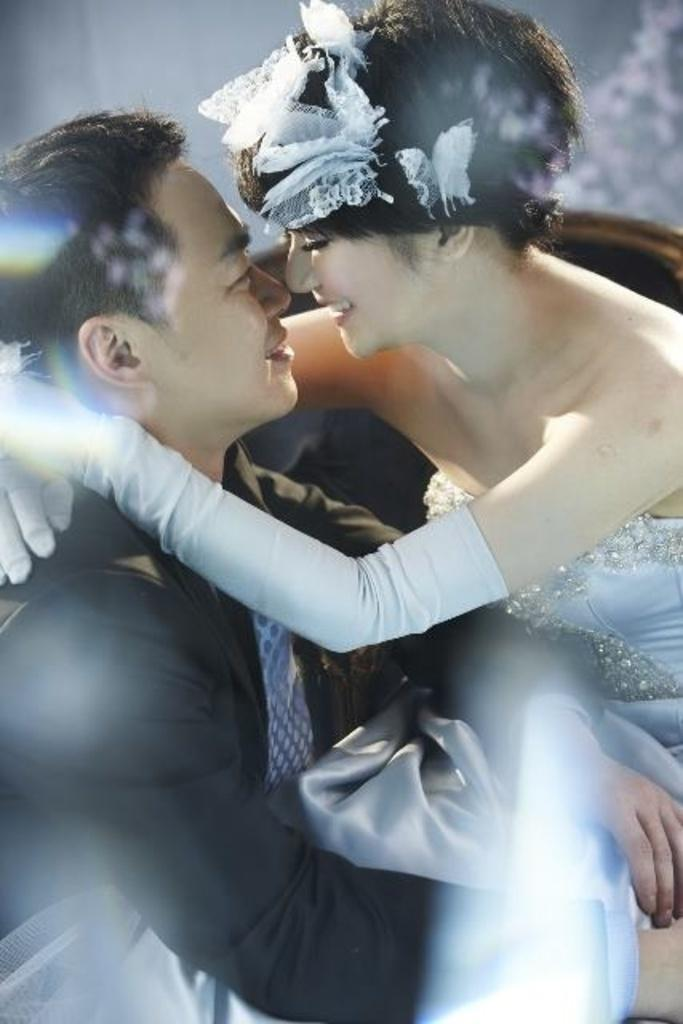Who is present in the image? There is a couple in the image. Where are they sitting? The couple is sitting in the front. What expression do they have? The couple is smiling. How would you describe the background of the image? The background of the image is blurred. How many cows can be seen in the image? There are no cows present in the image. What type of cannon is visible in the background? There is no cannon present in the image. 